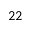<formula> <loc_0><loc_0><loc_500><loc_500>2 2</formula> 